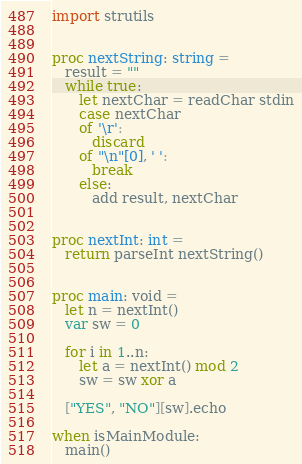Convert code to text. <code><loc_0><loc_0><loc_500><loc_500><_Nim_>import strutils


proc nextString: string =
   result = ""
   while true:
      let nextChar = readChar stdin
      case nextChar
      of '\r':
         discard
      of "\n"[0], ' ':
         break
      else:
         add result, nextChar


proc nextInt: int =
   return parseInt nextString()


proc main: void =
   let n = nextInt()
   var sw = 0

   for i in 1..n:
      let a = nextInt() mod 2
      sw = sw xor a

   ["YES", "NO"][sw].echo

when isMainModule:
   main()
</code> 